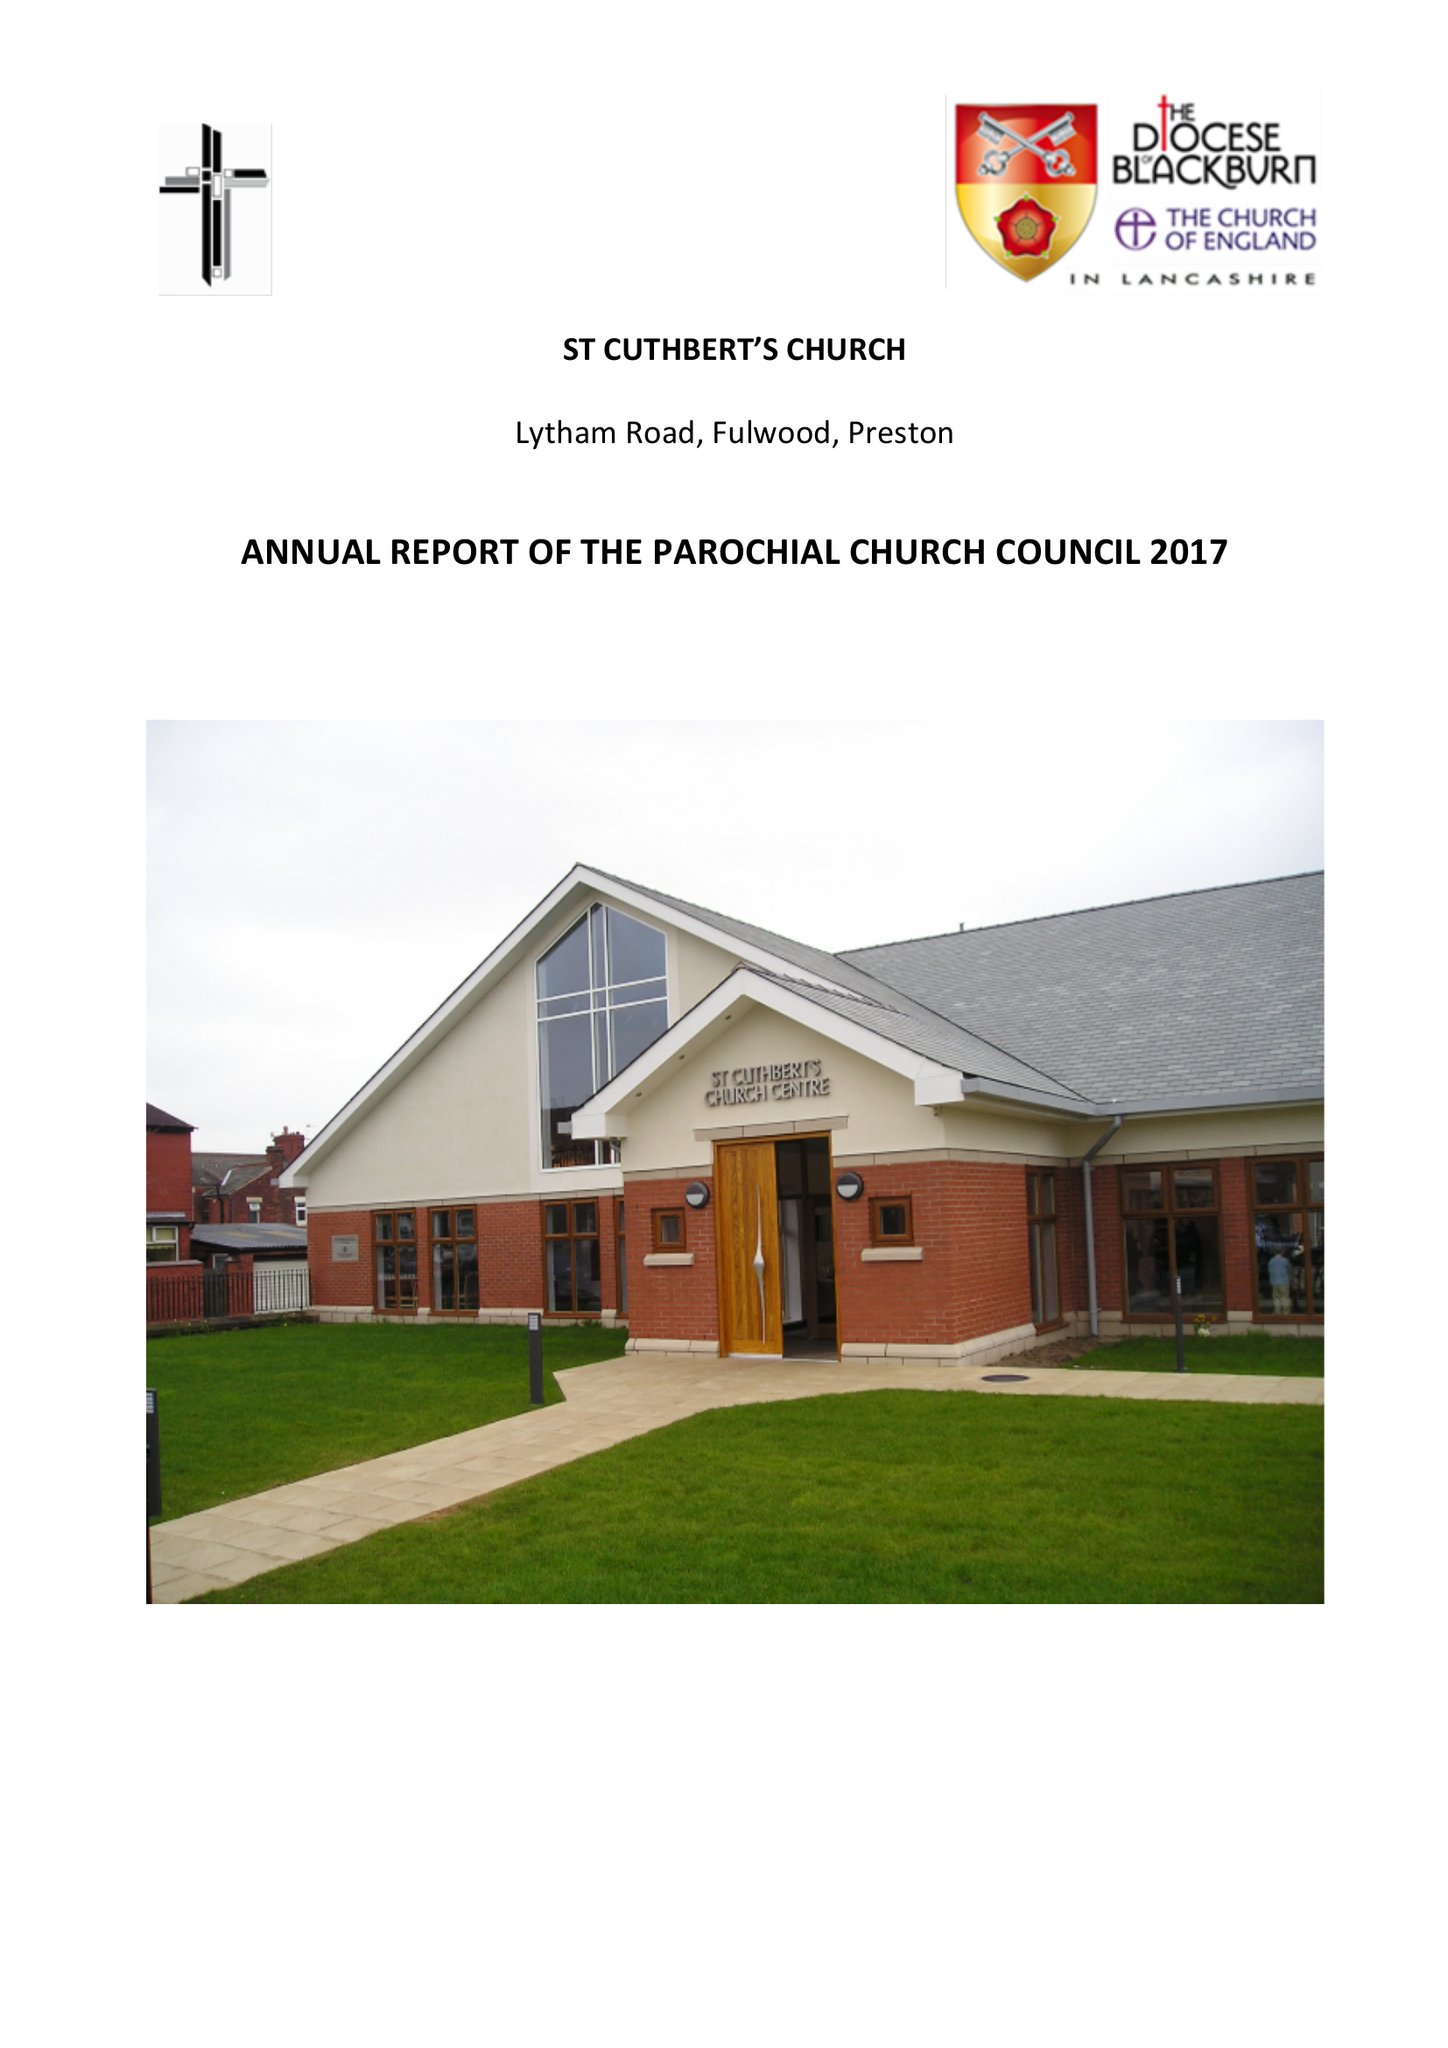What is the value for the charity_name?
Answer the question using a single word or phrase. St Cuthbert's Church 